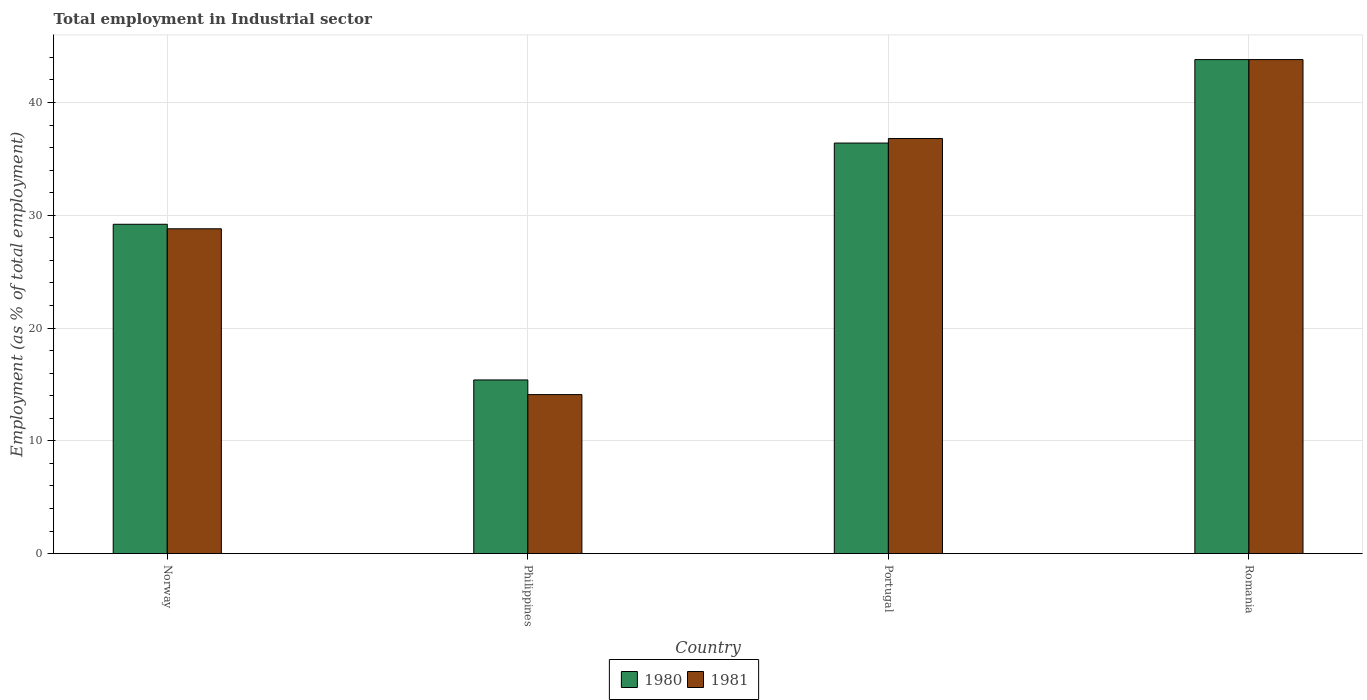How many groups of bars are there?
Your response must be concise. 4. How many bars are there on the 2nd tick from the left?
Keep it short and to the point. 2. What is the label of the 4th group of bars from the left?
Your answer should be very brief. Romania. What is the employment in industrial sector in 1981 in Portugal?
Make the answer very short. 36.8. Across all countries, what is the maximum employment in industrial sector in 1980?
Offer a terse response. 43.8. Across all countries, what is the minimum employment in industrial sector in 1981?
Your answer should be compact. 14.1. In which country was the employment in industrial sector in 1980 maximum?
Provide a short and direct response. Romania. What is the total employment in industrial sector in 1981 in the graph?
Provide a succinct answer. 123.5. What is the difference between the employment in industrial sector in 1981 in Philippines and that in Romania?
Give a very brief answer. -29.7. What is the difference between the employment in industrial sector in 1980 in Romania and the employment in industrial sector in 1981 in Philippines?
Your response must be concise. 29.7. What is the average employment in industrial sector in 1980 per country?
Ensure brevity in your answer.  31.2. What is the difference between the employment in industrial sector of/in 1980 and employment in industrial sector of/in 1981 in Philippines?
Give a very brief answer. 1.3. What is the ratio of the employment in industrial sector in 1980 in Philippines to that in Romania?
Give a very brief answer. 0.35. What is the difference between the highest and the second highest employment in industrial sector in 1980?
Offer a very short reply. 7.4. What is the difference between the highest and the lowest employment in industrial sector in 1981?
Provide a short and direct response. 29.7. In how many countries, is the employment in industrial sector in 1981 greater than the average employment in industrial sector in 1981 taken over all countries?
Offer a terse response. 2. Is the sum of the employment in industrial sector in 1980 in Norway and Romania greater than the maximum employment in industrial sector in 1981 across all countries?
Provide a succinct answer. Yes. What does the 1st bar from the left in Norway represents?
Offer a terse response. 1980. Does the graph contain grids?
Provide a succinct answer. Yes. Where does the legend appear in the graph?
Keep it short and to the point. Bottom center. How many legend labels are there?
Your answer should be compact. 2. What is the title of the graph?
Provide a short and direct response. Total employment in Industrial sector. What is the label or title of the Y-axis?
Provide a short and direct response. Employment (as % of total employment). What is the Employment (as % of total employment) of 1980 in Norway?
Make the answer very short. 29.2. What is the Employment (as % of total employment) of 1981 in Norway?
Your response must be concise. 28.8. What is the Employment (as % of total employment) in 1980 in Philippines?
Your answer should be very brief. 15.4. What is the Employment (as % of total employment) in 1981 in Philippines?
Offer a terse response. 14.1. What is the Employment (as % of total employment) in 1980 in Portugal?
Your response must be concise. 36.4. What is the Employment (as % of total employment) in 1981 in Portugal?
Your answer should be very brief. 36.8. What is the Employment (as % of total employment) in 1980 in Romania?
Provide a short and direct response. 43.8. What is the Employment (as % of total employment) of 1981 in Romania?
Give a very brief answer. 43.8. Across all countries, what is the maximum Employment (as % of total employment) of 1980?
Ensure brevity in your answer.  43.8. Across all countries, what is the maximum Employment (as % of total employment) in 1981?
Ensure brevity in your answer.  43.8. Across all countries, what is the minimum Employment (as % of total employment) in 1980?
Ensure brevity in your answer.  15.4. Across all countries, what is the minimum Employment (as % of total employment) of 1981?
Give a very brief answer. 14.1. What is the total Employment (as % of total employment) of 1980 in the graph?
Ensure brevity in your answer.  124.8. What is the total Employment (as % of total employment) of 1981 in the graph?
Give a very brief answer. 123.5. What is the difference between the Employment (as % of total employment) in 1980 in Norway and that in Philippines?
Keep it short and to the point. 13.8. What is the difference between the Employment (as % of total employment) of 1981 in Norway and that in Philippines?
Keep it short and to the point. 14.7. What is the difference between the Employment (as % of total employment) of 1980 in Norway and that in Romania?
Keep it short and to the point. -14.6. What is the difference between the Employment (as % of total employment) in 1981 in Philippines and that in Portugal?
Give a very brief answer. -22.7. What is the difference between the Employment (as % of total employment) in 1980 in Philippines and that in Romania?
Keep it short and to the point. -28.4. What is the difference between the Employment (as % of total employment) in 1981 in Philippines and that in Romania?
Make the answer very short. -29.7. What is the difference between the Employment (as % of total employment) in 1981 in Portugal and that in Romania?
Make the answer very short. -7. What is the difference between the Employment (as % of total employment) in 1980 in Norway and the Employment (as % of total employment) in 1981 in Philippines?
Your response must be concise. 15.1. What is the difference between the Employment (as % of total employment) in 1980 in Norway and the Employment (as % of total employment) in 1981 in Romania?
Your answer should be compact. -14.6. What is the difference between the Employment (as % of total employment) in 1980 in Philippines and the Employment (as % of total employment) in 1981 in Portugal?
Your answer should be very brief. -21.4. What is the difference between the Employment (as % of total employment) of 1980 in Philippines and the Employment (as % of total employment) of 1981 in Romania?
Provide a short and direct response. -28.4. What is the difference between the Employment (as % of total employment) of 1980 in Portugal and the Employment (as % of total employment) of 1981 in Romania?
Offer a terse response. -7.4. What is the average Employment (as % of total employment) of 1980 per country?
Your answer should be very brief. 31.2. What is the average Employment (as % of total employment) of 1981 per country?
Make the answer very short. 30.88. What is the difference between the Employment (as % of total employment) in 1980 and Employment (as % of total employment) in 1981 in Norway?
Ensure brevity in your answer.  0.4. What is the difference between the Employment (as % of total employment) of 1980 and Employment (as % of total employment) of 1981 in Philippines?
Provide a succinct answer. 1.3. What is the difference between the Employment (as % of total employment) in 1980 and Employment (as % of total employment) in 1981 in Romania?
Make the answer very short. 0. What is the ratio of the Employment (as % of total employment) of 1980 in Norway to that in Philippines?
Provide a short and direct response. 1.9. What is the ratio of the Employment (as % of total employment) in 1981 in Norway to that in Philippines?
Ensure brevity in your answer.  2.04. What is the ratio of the Employment (as % of total employment) in 1980 in Norway to that in Portugal?
Provide a succinct answer. 0.8. What is the ratio of the Employment (as % of total employment) of 1981 in Norway to that in Portugal?
Provide a short and direct response. 0.78. What is the ratio of the Employment (as % of total employment) of 1981 in Norway to that in Romania?
Offer a terse response. 0.66. What is the ratio of the Employment (as % of total employment) in 1980 in Philippines to that in Portugal?
Give a very brief answer. 0.42. What is the ratio of the Employment (as % of total employment) of 1981 in Philippines to that in Portugal?
Your response must be concise. 0.38. What is the ratio of the Employment (as % of total employment) in 1980 in Philippines to that in Romania?
Your answer should be compact. 0.35. What is the ratio of the Employment (as % of total employment) of 1981 in Philippines to that in Romania?
Offer a terse response. 0.32. What is the ratio of the Employment (as % of total employment) of 1980 in Portugal to that in Romania?
Provide a succinct answer. 0.83. What is the ratio of the Employment (as % of total employment) of 1981 in Portugal to that in Romania?
Offer a terse response. 0.84. What is the difference between the highest and the second highest Employment (as % of total employment) of 1980?
Offer a terse response. 7.4. What is the difference between the highest and the lowest Employment (as % of total employment) in 1980?
Your answer should be very brief. 28.4. What is the difference between the highest and the lowest Employment (as % of total employment) of 1981?
Your response must be concise. 29.7. 